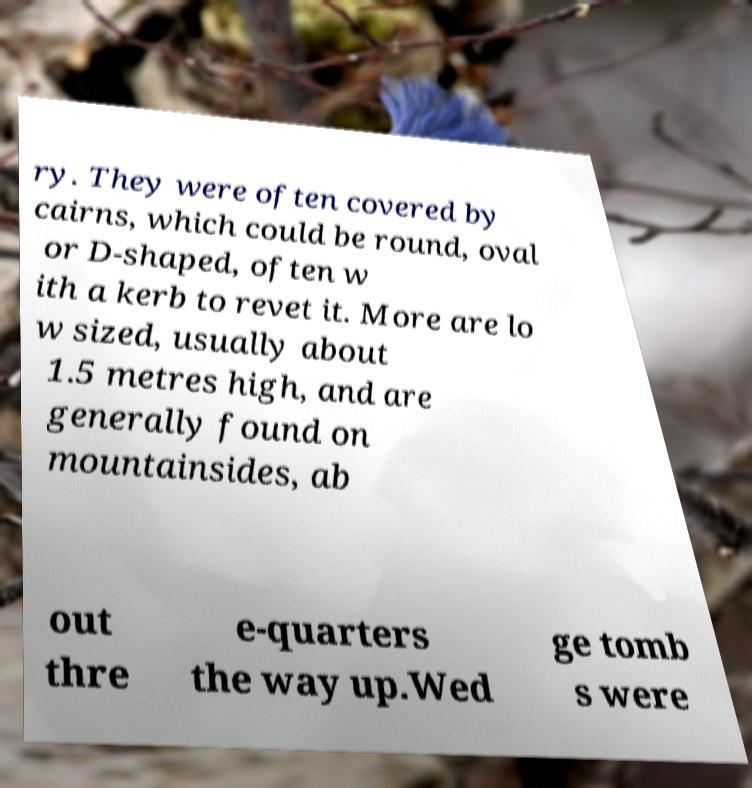Please read and relay the text visible in this image. What does it say? ry. They were often covered by cairns, which could be round, oval or D-shaped, often w ith a kerb to revet it. More are lo w sized, usually about 1.5 metres high, and are generally found on mountainsides, ab out thre e-quarters the way up.Wed ge tomb s were 